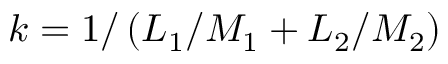Convert formula to latex. <formula><loc_0><loc_0><loc_500><loc_500>k = 1 / \left ( L _ { 1 } / M _ { 1 } + L _ { 2 } / M _ { 2 } \right )</formula> 